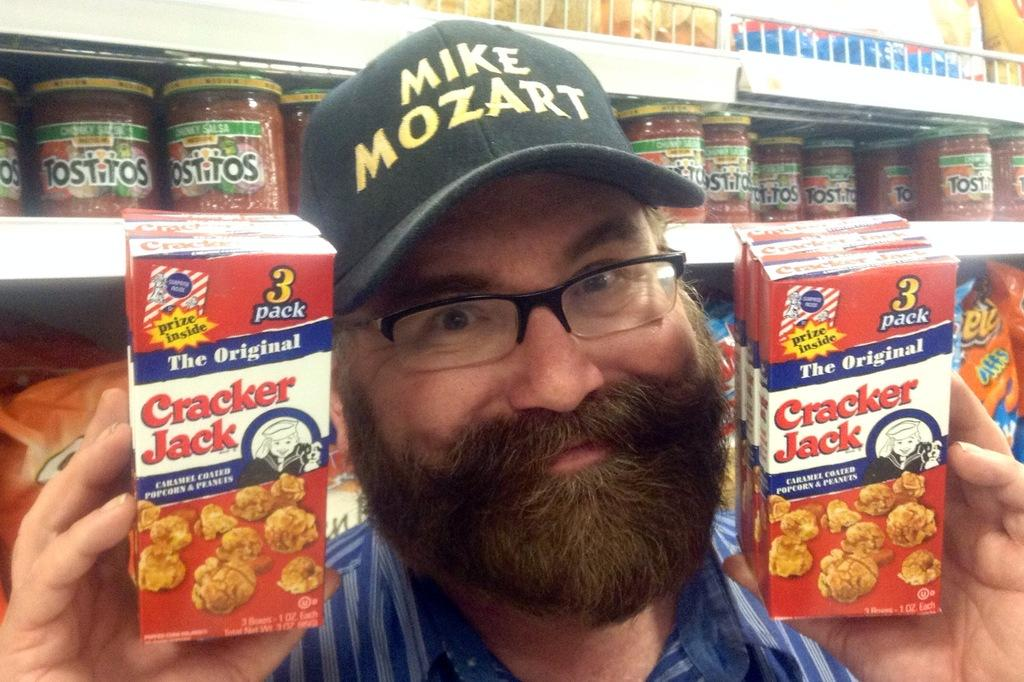Who is present in the image? There is a person in the image. What is the person holding in his hand? The person is holding objects in his hand. Can you describe the person's attire? The person is wearing a cap on his head. What can be seen in the background of the image? There are products placed in the racks in the background. What time does the clock show in the image? There is no clock present in the image. Are there any police officers visible in the image? There are no police officers present in the image. 